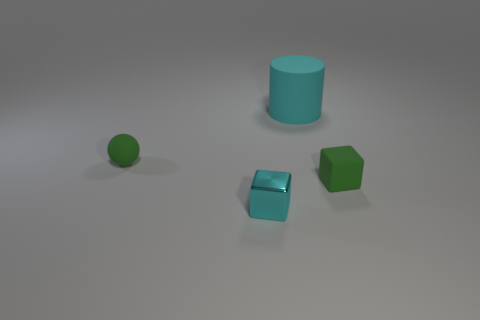Add 2 matte blocks. How many objects exist? 6 Subtract all spheres. How many objects are left? 3 Add 2 metal cubes. How many metal cubes are left? 3 Add 1 small green rubber blocks. How many small green rubber blocks exist? 2 Subtract 0 red cylinders. How many objects are left? 4 Subtract all large rubber things. Subtract all tiny cylinders. How many objects are left? 3 